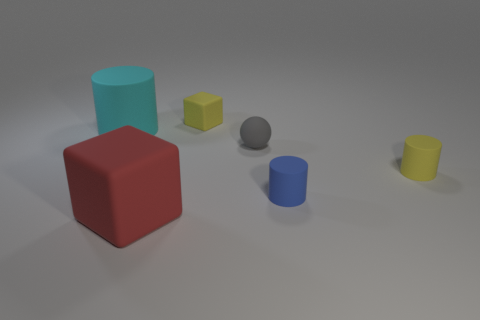The matte cylinder that is the same color as the tiny block is what size?
Offer a terse response. Small. There is a rubber thing that is the same color as the small rubber cube; what shape is it?
Ensure brevity in your answer.  Cylinder. Is the shape of the big object behind the big red block the same as  the blue thing?
Make the answer very short. Yes. Are there any other small gray objects of the same shape as the gray object?
Provide a succinct answer. No. What number of things are either tiny rubber things in front of the small rubber cube or big cyan things?
Offer a terse response. 4. Is the number of big gray metallic spheres greater than the number of tiny blue rubber cylinders?
Give a very brief answer. No. Is there a gray metal cylinder of the same size as the red matte object?
Ensure brevity in your answer.  No. What number of objects are matte objects that are left of the tiny blue matte cylinder or yellow rubber things in front of the big cyan matte cylinder?
Your response must be concise. 5. There is a large thing that is in front of the cylinder that is behind the yellow rubber cylinder; what is its color?
Your answer should be compact. Red. What is the color of the tiny block that is made of the same material as the large cyan cylinder?
Ensure brevity in your answer.  Yellow. 